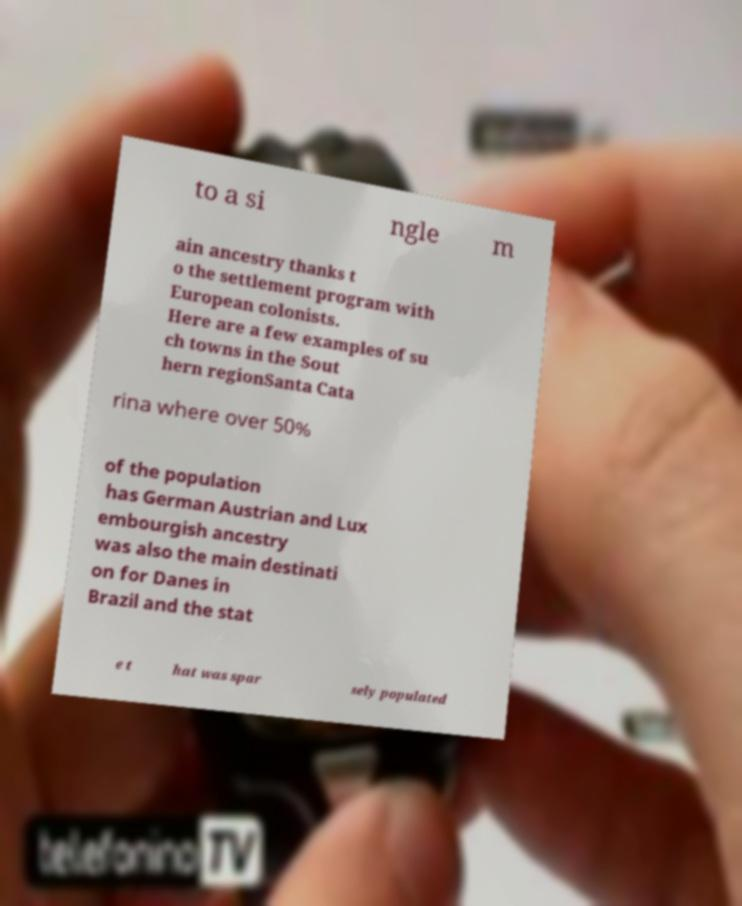Could you assist in decoding the text presented in this image and type it out clearly? to a si ngle m ain ancestry thanks t o the settlement program with European colonists. Here are a few examples of su ch towns in the Sout hern regionSanta Cata rina where over 50% of the population has German Austrian and Lux embourgish ancestry was also the main destinati on for Danes in Brazil and the stat e t hat was spar sely populated 